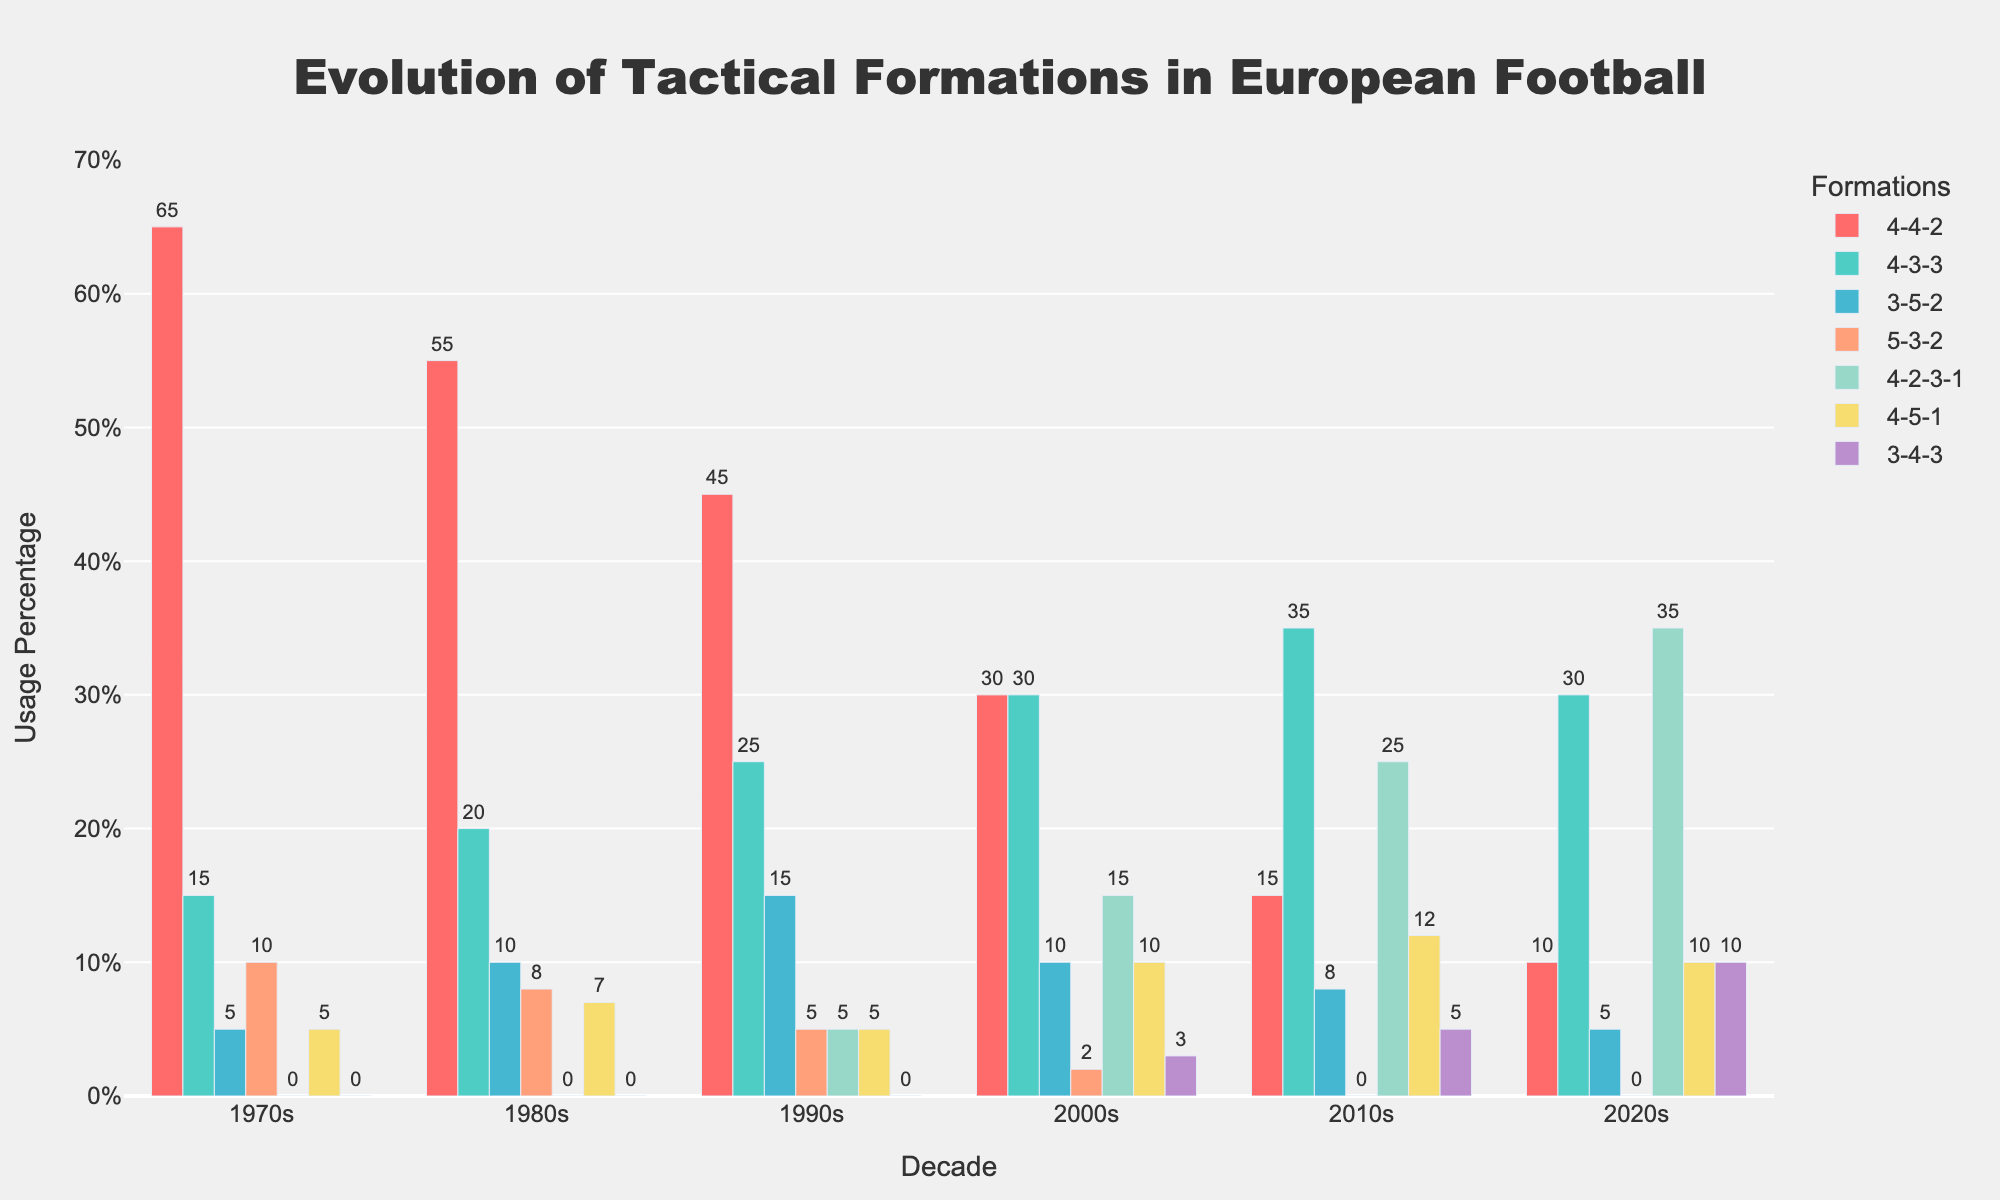Which decade saw the highest use of the 4-4-2 formation? To determine this, look at the heights of the bars representing the 4-4-2 formation for all decades. The tallest bar corresponds to the 1970s.
Answer: 1970s In which decade was the 4-2-3-1 formation most popular? Examine the bars for the 4-2-3-1 formation across all decades. The tallest bar for this formation is in the 2020s.
Answer: 2020s What is the difference in the usage percentage of the 4-4-2 formation between the 1970s and 2020s? The heights of the bars for the 4-4-2 formation are 65% (1970s) and 10% (2020s). Subtract 10% from 65%.
Answer: 55% In the 2000s, how many formations have a usage percentage higher than 10%? Look at the bars for the 2000s. The 4-4-2, 4-3-3, and 4-2-3-1 formations are above 10%, resulting in three formations.
Answer: 3 Which formation saw a continuous increase in usage percentage from the 1970s to the 2020s? Consider each formation's bar values over the decades. The 4-2-3-1 formation shows a consistent increase from 0% in the 1970s to 35% in the 2020s.
Answer: 4-2-3-1 How does the usage of the 3-5-2 formation in the 1990s compare to that in the 2020s? Examine the bars for the 3-5-2 formation in the 1990s (15%) and 2020s (5%). The bar in the 1990s is taller.
Answer: More in the 1990s What is the combined usage percentage of the 4-3-3 and 4-5-1 formations in the 2010s? Add the heights of the bars for the 4-3-3 (35%) and 4-5-1 (12%) formations in the 2010s.
Answer: 47% Which formation had the least usage in the 1970s? Identify the shortest bar in the 1970s. The formations 4-2-3-1 and 3-4-3 each have a 0% usage.
Answer: 4-2-3-1 and 3-4-3 Is the usage percentage of the 5-3-2 formation in the 1980s greater than that of the 3-4-3 formation in the 2020s? Compare the heights of the bars: The 5-3-2 formation in the 1980s is 8%, while the 3-4-3 formation in the 2020s is 10%.
Answer: No What is the average usage percentage of the formations in the 1980s? Calculate the sum of the percentages for all formations in the 1980s (55+20+10+8+0+7+0=100) and divide it by the number of formations (7).
Answer: 14.3% 